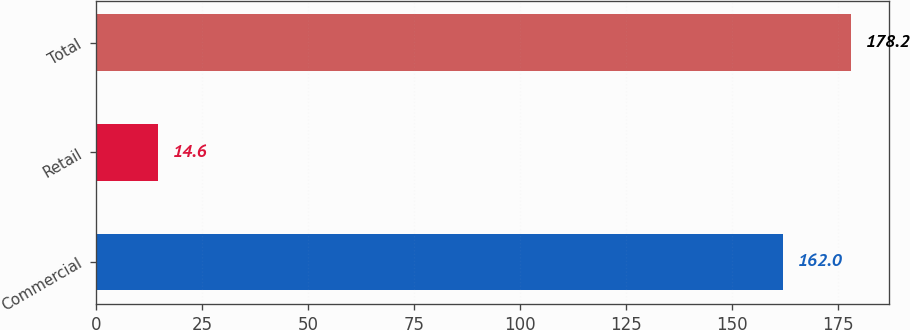<chart> <loc_0><loc_0><loc_500><loc_500><bar_chart><fcel>Commercial<fcel>Retail<fcel>Total<nl><fcel>162<fcel>14.6<fcel>178.2<nl></chart> 